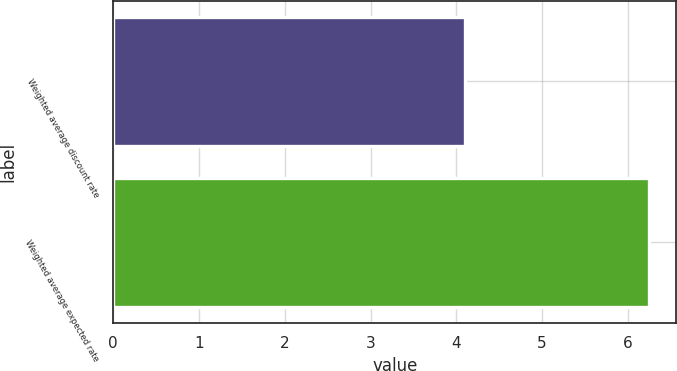Convert chart to OTSL. <chart><loc_0><loc_0><loc_500><loc_500><bar_chart><fcel>Weighted average discount rate<fcel>Weighted average expected rate<nl><fcel>4.1<fcel>6.25<nl></chart> 